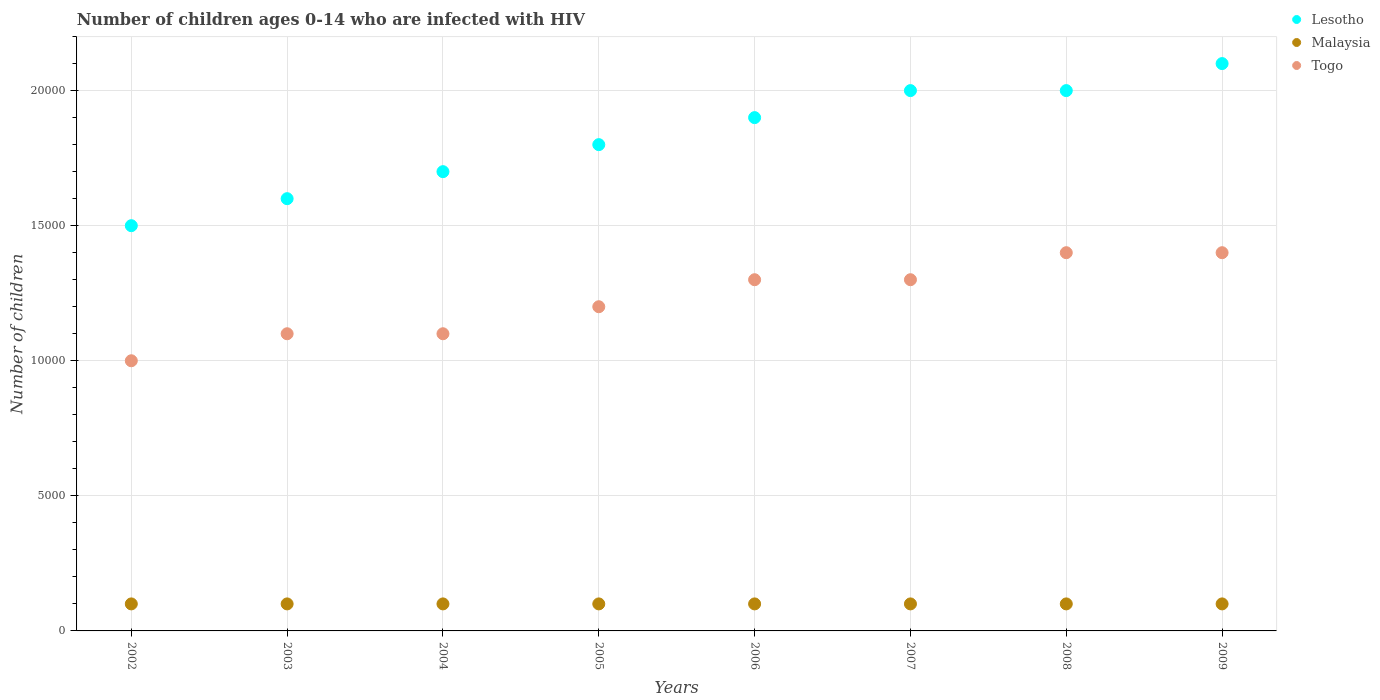Is the number of dotlines equal to the number of legend labels?
Provide a short and direct response. Yes. What is the number of HIV infected children in Lesotho in 2003?
Make the answer very short. 1.60e+04. Across all years, what is the maximum number of HIV infected children in Togo?
Your answer should be compact. 1.40e+04. Across all years, what is the minimum number of HIV infected children in Lesotho?
Your answer should be compact. 1.50e+04. In which year was the number of HIV infected children in Togo minimum?
Keep it short and to the point. 2002. What is the total number of HIV infected children in Malaysia in the graph?
Give a very brief answer. 8000. What is the difference between the number of HIV infected children in Togo in 2002 and that in 2005?
Ensure brevity in your answer.  -2000. What is the difference between the number of HIV infected children in Malaysia in 2005 and the number of HIV infected children in Togo in 2009?
Offer a very short reply. -1.30e+04. What is the average number of HIV infected children in Togo per year?
Provide a short and direct response. 1.22e+04. In the year 2004, what is the difference between the number of HIV infected children in Togo and number of HIV infected children in Lesotho?
Ensure brevity in your answer.  -6000. What is the ratio of the number of HIV infected children in Lesotho in 2006 to that in 2009?
Provide a succinct answer. 0.9. Is the number of HIV infected children in Lesotho in 2002 less than that in 2003?
Your response must be concise. Yes. What is the difference between the highest and the lowest number of HIV infected children in Lesotho?
Provide a succinct answer. 6000. In how many years, is the number of HIV infected children in Lesotho greater than the average number of HIV infected children in Lesotho taken over all years?
Keep it short and to the point. 4. Is it the case that in every year, the sum of the number of HIV infected children in Togo and number of HIV infected children in Malaysia  is greater than the number of HIV infected children in Lesotho?
Your answer should be compact. No. Is the number of HIV infected children in Togo strictly greater than the number of HIV infected children in Lesotho over the years?
Provide a succinct answer. No. How many dotlines are there?
Your answer should be compact. 3. Are the values on the major ticks of Y-axis written in scientific E-notation?
Provide a succinct answer. No. Does the graph contain grids?
Your response must be concise. Yes. How many legend labels are there?
Provide a short and direct response. 3. How are the legend labels stacked?
Keep it short and to the point. Vertical. What is the title of the graph?
Your answer should be compact. Number of children ages 0-14 who are infected with HIV. What is the label or title of the X-axis?
Offer a terse response. Years. What is the label or title of the Y-axis?
Your answer should be compact. Number of children. What is the Number of children in Lesotho in 2002?
Make the answer very short. 1.50e+04. What is the Number of children in Malaysia in 2002?
Make the answer very short. 1000. What is the Number of children of Lesotho in 2003?
Provide a short and direct response. 1.60e+04. What is the Number of children of Malaysia in 2003?
Ensure brevity in your answer.  1000. What is the Number of children of Togo in 2003?
Make the answer very short. 1.10e+04. What is the Number of children of Lesotho in 2004?
Your response must be concise. 1.70e+04. What is the Number of children in Malaysia in 2004?
Give a very brief answer. 1000. What is the Number of children of Togo in 2004?
Offer a terse response. 1.10e+04. What is the Number of children in Lesotho in 2005?
Provide a short and direct response. 1.80e+04. What is the Number of children of Malaysia in 2005?
Make the answer very short. 1000. What is the Number of children of Togo in 2005?
Your response must be concise. 1.20e+04. What is the Number of children of Lesotho in 2006?
Keep it short and to the point. 1.90e+04. What is the Number of children of Togo in 2006?
Your answer should be very brief. 1.30e+04. What is the Number of children in Lesotho in 2007?
Provide a short and direct response. 2.00e+04. What is the Number of children of Togo in 2007?
Your answer should be very brief. 1.30e+04. What is the Number of children in Lesotho in 2008?
Provide a succinct answer. 2.00e+04. What is the Number of children in Togo in 2008?
Ensure brevity in your answer.  1.40e+04. What is the Number of children of Lesotho in 2009?
Your answer should be very brief. 2.10e+04. What is the Number of children of Togo in 2009?
Keep it short and to the point. 1.40e+04. Across all years, what is the maximum Number of children of Lesotho?
Give a very brief answer. 2.10e+04. Across all years, what is the maximum Number of children of Togo?
Give a very brief answer. 1.40e+04. Across all years, what is the minimum Number of children in Lesotho?
Provide a succinct answer. 1.50e+04. Across all years, what is the minimum Number of children of Malaysia?
Ensure brevity in your answer.  1000. Across all years, what is the minimum Number of children in Togo?
Ensure brevity in your answer.  10000. What is the total Number of children of Lesotho in the graph?
Your answer should be very brief. 1.46e+05. What is the total Number of children in Malaysia in the graph?
Your answer should be compact. 8000. What is the total Number of children in Togo in the graph?
Offer a very short reply. 9.80e+04. What is the difference between the Number of children in Lesotho in 2002 and that in 2003?
Provide a short and direct response. -1000. What is the difference between the Number of children of Togo in 2002 and that in 2003?
Provide a succinct answer. -1000. What is the difference between the Number of children of Lesotho in 2002 and that in 2004?
Give a very brief answer. -2000. What is the difference between the Number of children in Togo in 2002 and that in 2004?
Give a very brief answer. -1000. What is the difference between the Number of children of Lesotho in 2002 and that in 2005?
Provide a succinct answer. -3000. What is the difference between the Number of children in Togo in 2002 and that in 2005?
Your answer should be very brief. -2000. What is the difference between the Number of children of Lesotho in 2002 and that in 2006?
Give a very brief answer. -4000. What is the difference between the Number of children in Togo in 2002 and that in 2006?
Give a very brief answer. -3000. What is the difference between the Number of children of Lesotho in 2002 and that in 2007?
Provide a short and direct response. -5000. What is the difference between the Number of children in Togo in 2002 and that in 2007?
Offer a very short reply. -3000. What is the difference between the Number of children in Lesotho in 2002 and that in 2008?
Give a very brief answer. -5000. What is the difference between the Number of children in Togo in 2002 and that in 2008?
Provide a short and direct response. -4000. What is the difference between the Number of children of Lesotho in 2002 and that in 2009?
Keep it short and to the point. -6000. What is the difference between the Number of children in Togo in 2002 and that in 2009?
Give a very brief answer. -4000. What is the difference between the Number of children of Lesotho in 2003 and that in 2004?
Provide a short and direct response. -1000. What is the difference between the Number of children in Malaysia in 2003 and that in 2004?
Your response must be concise. 0. What is the difference between the Number of children of Togo in 2003 and that in 2004?
Offer a very short reply. 0. What is the difference between the Number of children in Lesotho in 2003 and that in 2005?
Keep it short and to the point. -2000. What is the difference between the Number of children of Togo in 2003 and that in 2005?
Offer a very short reply. -1000. What is the difference between the Number of children of Lesotho in 2003 and that in 2006?
Your answer should be compact. -3000. What is the difference between the Number of children in Togo in 2003 and that in 2006?
Your answer should be very brief. -2000. What is the difference between the Number of children in Lesotho in 2003 and that in 2007?
Ensure brevity in your answer.  -4000. What is the difference between the Number of children in Malaysia in 2003 and that in 2007?
Keep it short and to the point. 0. What is the difference between the Number of children of Togo in 2003 and that in 2007?
Your response must be concise. -2000. What is the difference between the Number of children of Lesotho in 2003 and that in 2008?
Keep it short and to the point. -4000. What is the difference between the Number of children of Malaysia in 2003 and that in 2008?
Offer a terse response. 0. What is the difference between the Number of children in Togo in 2003 and that in 2008?
Provide a short and direct response. -3000. What is the difference between the Number of children in Lesotho in 2003 and that in 2009?
Offer a terse response. -5000. What is the difference between the Number of children of Malaysia in 2003 and that in 2009?
Make the answer very short. 0. What is the difference between the Number of children of Togo in 2003 and that in 2009?
Keep it short and to the point. -3000. What is the difference between the Number of children in Lesotho in 2004 and that in 2005?
Keep it short and to the point. -1000. What is the difference between the Number of children of Togo in 2004 and that in 2005?
Ensure brevity in your answer.  -1000. What is the difference between the Number of children of Lesotho in 2004 and that in 2006?
Your response must be concise. -2000. What is the difference between the Number of children in Togo in 2004 and that in 2006?
Ensure brevity in your answer.  -2000. What is the difference between the Number of children of Lesotho in 2004 and that in 2007?
Give a very brief answer. -3000. What is the difference between the Number of children of Malaysia in 2004 and that in 2007?
Provide a short and direct response. 0. What is the difference between the Number of children in Togo in 2004 and that in 2007?
Your answer should be very brief. -2000. What is the difference between the Number of children in Lesotho in 2004 and that in 2008?
Your answer should be compact. -3000. What is the difference between the Number of children of Togo in 2004 and that in 2008?
Keep it short and to the point. -3000. What is the difference between the Number of children in Lesotho in 2004 and that in 2009?
Give a very brief answer. -4000. What is the difference between the Number of children of Malaysia in 2004 and that in 2009?
Provide a short and direct response. 0. What is the difference between the Number of children in Togo in 2004 and that in 2009?
Ensure brevity in your answer.  -3000. What is the difference between the Number of children of Lesotho in 2005 and that in 2006?
Your answer should be compact. -1000. What is the difference between the Number of children of Malaysia in 2005 and that in 2006?
Your response must be concise. 0. What is the difference between the Number of children of Togo in 2005 and that in 2006?
Your answer should be compact. -1000. What is the difference between the Number of children of Lesotho in 2005 and that in 2007?
Make the answer very short. -2000. What is the difference between the Number of children of Togo in 2005 and that in 2007?
Offer a terse response. -1000. What is the difference between the Number of children in Lesotho in 2005 and that in 2008?
Make the answer very short. -2000. What is the difference between the Number of children in Malaysia in 2005 and that in 2008?
Your answer should be compact. 0. What is the difference between the Number of children in Togo in 2005 and that in 2008?
Offer a terse response. -2000. What is the difference between the Number of children in Lesotho in 2005 and that in 2009?
Provide a succinct answer. -3000. What is the difference between the Number of children in Togo in 2005 and that in 2009?
Make the answer very short. -2000. What is the difference between the Number of children in Lesotho in 2006 and that in 2007?
Your answer should be compact. -1000. What is the difference between the Number of children of Lesotho in 2006 and that in 2008?
Offer a very short reply. -1000. What is the difference between the Number of children in Togo in 2006 and that in 2008?
Offer a very short reply. -1000. What is the difference between the Number of children of Lesotho in 2006 and that in 2009?
Your answer should be compact. -2000. What is the difference between the Number of children of Togo in 2006 and that in 2009?
Your response must be concise. -1000. What is the difference between the Number of children in Togo in 2007 and that in 2008?
Your response must be concise. -1000. What is the difference between the Number of children in Lesotho in 2007 and that in 2009?
Provide a succinct answer. -1000. What is the difference between the Number of children in Malaysia in 2007 and that in 2009?
Offer a terse response. 0. What is the difference between the Number of children in Togo in 2007 and that in 2009?
Make the answer very short. -1000. What is the difference between the Number of children of Lesotho in 2008 and that in 2009?
Keep it short and to the point. -1000. What is the difference between the Number of children in Lesotho in 2002 and the Number of children in Malaysia in 2003?
Your response must be concise. 1.40e+04. What is the difference between the Number of children of Lesotho in 2002 and the Number of children of Togo in 2003?
Keep it short and to the point. 4000. What is the difference between the Number of children in Malaysia in 2002 and the Number of children in Togo in 2003?
Your response must be concise. -10000. What is the difference between the Number of children in Lesotho in 2002 and the Number of children in Malaysia in 2004?
Your answer should be very brief. 1.40e+04. What is the difference between the Number of children of Lesotho in 2002 and the Number of children of Togo in 2004?
Keep it short and to the point. 4000. What is the difference between the Number of children of Lesotho in 2002 and the Number of children of Malaysia in 2005?
Ensure brevity in your answer.  1.40e+04. What is the difference between the Number of children of Lesotho in 2002 and the Number of children of Togo in 2005?
Provide a short and direct response. 3000. What is the difference between the Number of children in Malaysia in 2002 and the Number of children in Togo in 2005?
Make the answer very short. -1.10e+04. What is the difference between the Number of children of Lesotho in 2002 and the Number of children of Malaysia in 2006?
Keep it short and to the point. 1.40e+04. What is the difference between the Number of children in Malaysia in 2002 and the Number of children in Togo in 2006?
Provide a succinct answer. -1.20e+04. What is the difference between the Number of children in Lesotho in 2002 and the Number of children in Malaysia in 2007?
Ensure brevity in your answer.  1.40e+04. What is the difference between the Number of children in Malaysia in 2002 and the Number of children in Togo in 2007?
Ensure brevity in your answer.  -1.20e+04. What is the difference between the Number of children in Lesotho in 2002 and the Number of children in Malaysia in 2008?
Make the answer very short. 1.40e+04. What is the difference between the Number of children of Malaysia in 2002 and the Number of children of Togo in 2008?
Offer a very short reply. -1.30e+04. What is the difference between the Number of children in Lesotho in 2002 and the Number of children in Malaysia in 2009?
Your response must be concise. 1.40e+04. What is the difference between the Number of children in Lesotho in 2002 and the Number of children in Togo in 2009?
Provide a short and direct response. 1000. What is the difference between the Number of children in Malaysia in 2002 and the Number of children in Togo in 2009?
Keep it short and to the point. -1.30e+04. What is the difference between the Number of children of Lesotho in 2003 and the Number of children of Malaysia in 2004?
Keep it short and to the point. 1.50e+04. What is the difference between the Number of children of Lesotho in 2003 and the Number of children of Malaysia in 2005?
Your response must be concise. 1.50e+04. What is the difference between the Number of children of Lesotho in 2003 and the Number of children of Togo in 2005?
Make the answer very short. 4000. What is the difference between the Number of children in Malaysia in 2003 and the Number of children in Togo in 2005?
Provide a short and direct response. -1.10e+04. What is the difference between the Number of children in Lesotho in 2003 and the Number of children in Malaysia in 2006?
Your response must be concise. 1.50e+04. What is the difference between the Number of children of Lesotho in 2003 and the Number of children of Togo in 2006?
Offer a very short reply. 3000. What is the difference between the Number of children in Malaysia in 2003 and the Number of children in Togo in 2006?
Your answer should be very brief. -1.20e+04. What is the difference between the Number of children in Lesotho in 2003 and the Number of children in Malaysia in 2007?
Offer a very short reply. 1.50e+04. What is the difference between the Number of children of Lesotho in 2003 and the Number of children of Togo in 2007?
Ensure brevity in your answer.  3000. What is the difference between the Number of children of Malaysia in 2003 and the Number of children of Togo in 2007?
Your response must be concise. -1.20e+04. What is the difference between the Number of children in Lesotho in 2003 and the Number of children in Malaysia in 2008?
Provide a succinct answer. 1.50e+04. What is the difference between the Number of children of Lesotho in 2003 and the Number of children of Togo in 2008?
Ensure brevity in your answer.  2000. What is the difference between the Number of children in Malaysia in 2003 and the Number of children in Togo in 2008?
Provide a succinct answer. -1.30e+04. What is the difference between the Number of children of Lesotho in 2003 and the Number of children of Malaysia in 2009?
Your answer should be compact. 1.50e+04. What is the difference between the Number of children of Malaysia in 2003 and the Number of children of Togo in 2009?
Offer a terse response. -1.30e+04. What is the difference between the Number of children of Lesotho in 2004 and the Number of children of Malaysia in 2005?
Provide a short and direct response. 1.60e+04. What is the difference between the Number of children in Lesotho in 2004 and the Number of children in Togo in 2005?
Give a very brief answer. 5000. What is the difference between the Number of children of Malaysia in 2004 and the Number of children of Togo in 2005?
Provide a succinct answer. -1.10e+04. What is the difference between the Number of children of Lesotho in 2004 and the Number of children of Malaysia in 2006?
Your answer should be very brief. 1.60e+04. What is the difference between the Number of children in Lesotho in 2004 and the Number of children in Togo in 2006?
Give a very brief answer. 4000. What is the difference between the Number of children of Malaysia in 2004 and the Number of children of Togo in 2006?
Your response must be concise. -1.20e+04. What is the difference between the Number of children of Lesotho in 2004 and the Number of children of Malaysia in 2007?
Offer a very short reply. 1.60e+04. What is the difference between the Number of children of Lesotho in 2004 and the Number of children of Togo in 2007?
Your answer should be compact. 4000. What is the difference between the Number of children of Malaysia in 2004 and the Number of children of Togo in 2007?
Your answer should be compact. -1.20e+04. What is the difference between the Number of children in Lesotho in 2004 and the Number of children in Malaysia in 2008?
Make the answer very short. 1.60e+04. What is the difference between the Number of children of Lesotho in 2004 and the Number of children of Togo in 2008?
Offer a terse response. 3000. What is the difference between the Number of children of Malaysia in 2004 and the Number of children of Togo in 2008?
Keep it short and to the point. -1.30e+04. What is the difference between the Number of children in Lesotho in 2004 and the Number of children in Malaysia in 2009?
Your response must be concise. 1.60e+04. What is the difference between the Number of children in Lesotho in 2004 and the Number of children in Togo in 2009?
Give a very brief answer. 3000. What is the difference between the Number of children of Malaysia in 2004 and the Number of children of Togo in 2009?
Provide a succinct answer. -1.30e+04. What is the difference between the Number of children in Lesotho in 2005 and the Number of children in Malaysia in 2006?
Offer a very short reply. 1.70e+04. What is the difference between the Number of children in Lesotho in 2005 and the Number of children in Togo in 2006?
Your answer should be compact. 5000. What is the difference between the Number of children of Malaysia in 2005 and the Number of children of Togo in 2006?
Your response must be concise. -1.20e+04. What is the difference between the Number of children in Lesotho in 2005 and the Number of children in Malaysia in 2007?
Keep it short and to the point. 1.70e+04. What is the difference between the Number of children in Lesotho in 2005 and the Number of children in Togo in 2007?
Give a very brief answer. 5000. What is the difference between the Number of children in Malaysia in 2005 and the Number of children in Togo in 2007?
Provide a succinct answer. -1.20e+04. What is the difference between the Number of children of Lesotho in 2005 and the Number of children of Malaysia in 2008?
Your response must be concise. 1.70e+04. What is the difference between the Number of children in Lesotho in 2005 and the Number of children in Togo in 2008?
Provide a succinct answer. 4000. What is the difference between the Number of children of Malaysia in 2005 and the Number of children of Togo in 2008?
Provide a short and direct response. -1.30e+04. What is the difference between the Number of children in Lesotho in 2005 and the Number of children in Malaysia in 2009?
Your answer should be compact. 1.70e+04. What is the difference between the Number of children in Lesotho in 2005 and the Number of children in Togo in 2009?
Keep it short and to the point. 4000. What is the difference between the Number of children of Malaysia in 2005 and the Number of children of Togo in 2009?
Give a very brief answer. -1.30e+04. What is the difference between the Number of children in Lesotho in 2006 and the Number of children in Malaysia in 2007?
Offer a terse response. 1.80e+04. What is the difference between the Number of children of Lesotho in 2006 and the Number of children of Togo in 2007?
Provide a short and direct response. 6000. What is the difference between the Number of children in Malaysia in 2006 and the Number of children in Togo in 2007?
Your answer should be very brief. -1.20e+04. What is the difference between the Number of children in Lesotho in 2006 and the Number of children in Malaysia in 2008?
Your answer should be very brief. 1.80e+04. What is the difference between the Number of children in Lesotho in 2006 and the Number of children in Togo in 2008?
Provide a succinct answer. 5000. What is the difference between the Number of children in Malaysia in 2006 and the Number of children in Togo in 2008?
Offer a terse response. -1.30e+04. What is the difference between the Number of children in Lesotho in 2006 and the Number of children in Malaysia in 2009?
Your response must be concise. 1.80e+04. What is the difference between the Number of children in Malaysia in 2006 and the Number of children in Togo in 2009?
Your answer should be very brief. -1.30e+04. What is the difference between the Number of children of Lesotho in 2007 and the Number of children of Malaysia in 2008?
Your answer should be very brief. 1.90e+04. What is the difference between the Number of children of Lesotho in 2007 and the Number of children of Togo in 2008?
Offer a very short reply. 6000. What is the difference between the Number of children of Malaysia in 2007 and the Number of children of Togo in 2008?
Offer a terse response. -1.30e+04. What is the difference between the Number of children in Lesotho in 2007 and the Number of children in Malaysia in 2009?
Offer a very short reply. 1.90e+04. What is the difference between the Number of children of Lesotho in 2007 and the Number of children of Togo in 2009?
Offer a very short reply. 6000. What is the difference between the Number of children of Malaysia in 2007 and the Number of children of Togo in 2009?
Offer a terse response. -1.30e+04. What is the difference between the Number of children of Lesotho in 2008 and the Number of children of Malaysia in 2009?
Make the answer very short. 1.90e+04. What is the difference between the Number of children in Lesotho in 2008 and the Number of children in Togo in 2009?
Provide a succinct answer. 6000. What is the difference between the Number of children in Malaysia in 2008 and the Number of children in Togo in 2009?
Provide a short and direct response. -1.30e+04. What is the average Number of children of Lesotho per year?
Give a very brief answer. 1.82e+04. What is the average Number of children in Togo per year?
Make the answer very short. 1.22e+04. In the year 2002, what is the difference between the Number of children in Lesotho and Number of children in Malaysia?
Your answer should be very brief. 1.40e+04. In the year 2002, what is the difference between the Number of children in Malaysia and Number of children in Togo?
Your answer should be compact. -9000. In the year 2003, what is the difference between the Number of children in Lesotho and Number of children in Malaysia?
Your response must be concise. 1.50e+04. In the year 2003, what is the difference between the Number of children in Malaysia and Number of children in Togo?
Provide a succinct answer. -10000. In the year 2004, what is the difference between the Number of children in Lesotho and Number of children in Malaysia?
Provide a succinct answer. 1.60e+04. In the year 2004, what is the difference between the Number of children of Lesotho and Number of children of Togo?
Your response must be concise. 6000. In the year 2004, what is the difference between the Number of children in Malaysia and Number of children in Togo?
Offer a terse response. -10000. In the year 2005, what is the difference between the Number of children in Lesotho and Number of children in Malaysia?
Your answer should be compact. 1.70e+04. In the year 2005, what is the difference between the Number of children in Lesotho and Number of children in Togo?
Your answer should be very brief. 6000. In the year 2005, what is the difference between the Number of children in Malaysia and Number of children in Togo?
Your answer should be very brief. -1.10e+04. In the year 2006, what is the difference between the Number of children in Lesotho and Number of children in Malaysia?
Your response must be concise. 1.80e+04. In the year 2006, what is the difference between the Number of children of Lesotho and Number of children of Togo?
Your answer should be very brief. 6000. In the year 2006, what is the difference between the Number of children in Malaysia and Number of children in Togo?
Your response must be concise. -1.20e+04. In the year 2007, what is the difference between the Number of children in Lesotho and Number of children in Malaysia?
Keep it short and to the point. 1.90e+04. In the year 2007, what is the difference between the Number of children in Lesotho and Number of children in Togo?
Make the answer very short. 7000. In the year 2007, what is the difference between the Number of children of Malaysia and Number of children of Togo?
Provide a succinct answer. -1.20e+04. In the year 2008, what is the difference between the Number of children in Lesotho and Number of children in Malaysia?
Keep it short and to the point. 1.90e+04. In the year 2008, what is the difference between the Number of children of Lesotho and Number of children of Togo?
Your answer should be very brief. 6000. In the year 2008, what is the difference between the Number of children in Malaysia and Number of children in Togo?
Give a very brief answer. -1.30e+04. In the year 2009, what is the difference between the Number of children of Lesotho and Number of children of Togo?
Offer a very short reply. 7000. In the year 2009, what is the difference between the Number of children of Malaysia and Number of children of Togo?
Your answer should be compact. -1.30e+04. What is the ratio of the Number of children of Lesotho in 2002 to that in 2004?
Your answer should be compact. 0.88. What is the ratio of the Number of children in Malaysia in 2002 to that in 2004?
Ensure brevity in your answer.  1. What is the ratio of the Number of children of Lesotho in 2002 to that in 2005?
Make the answer very short. 0.83. What is the ratio of the Number of children of Malaysia in 2002 to that in 2005?
Keep it short and to the point. 1. What is the ratio of the Number of children in Togo in 2002 to that in 2005?
Provide a succinct answer. 0.83. What is the ratio of the Number of children in Lesotho in 2002 to that in 2006?
Make the answer very short. 0.79. What is the ratio of the Number of children of Togo in 2002 to that in 2006?
Provide a succinct answer. 0.77. What is the ratio of the Number of children of Lesotho in 2002 to that in 2007?
Provide a succinct answer. 0.75. What is the ratio of the Number of children in Togo in 2002 to that in 2007?
Your answer should be very brief. 0.77. What is the ratio of the Number of children in Malaysia in 2002 to that in 2008?
Provide a short and direct response. 1. What is the ratio of the Number of children in Lesotho in 2002 to that in 2009?
Offer a terse response. 0.71. What is the ratio of the Number of children of Malaysia in 2002 to that in 2009?
Your answer should be very brief. 1. What is the ratio of the Number of children of Togo in 2002 to that in 2009?
Give a very brief answer. 0.71. What is the ratio of the Number of children in Lesotho in 2003 to that in 2004?
Your response must be concise. 0.94. What is the ratio of the Number of children in Malaysia in 2003 to that in 2004?
Keep it short and to the point. 1. What is the ratio of the Number of children in Togo in 2003 to that in 2004?
Provide a succinct answer. 1. What is the ratio of the Number of children of Lesotho in 2003 to that in 2006?
Ensure brevity in your answer.  0.84. What is the ratio of the Number of children in Togo in 2003 to that in 2006?
Your response must be concise. 0.85. What is the ratio of the Number of children of Lesotho in 2003 to that in 2007?
Make the answer very short. 0.8. What is the ratio of the Number of children in Malaysia in 2003 to that in 2007?
Make the answer very short. 1. What is the ratio of the Number of children of Togo in 2003 to that in 2007?
Give a very brief answer. 0.85. What is the ratio of the Number of children of Togo in 2003 to that in 2008?
Provide a short and direct response. 0.79. What is the ratio of the Number of children in Lesotho in 2003 to that in 2009?
Your answer should be very brief. 0.76. What is the ratio of the Number of children of Malaysia in 2003 to that in 2009?
Ensure brevity in your answer.  1. What is the ratio of the Number of children of Togo in 2003 to that in 2009?
Ensure brevity in your answer.  0.79. What is the ratio of the Number of children of Lesotho in 2004 to that in 2005?
Provide a succinct answer. 0.94. What is the ratio of the Number of children in Lesotho in 2004 to that in 2006?
Your response must be concise. 0.89. What is the ratio of the Number of children in Malaysia in 2004 to that in 2006?
Provide a succinct answer. 1. What is the ratio of the Number of children in Togo in 2004 to that in 2006?
Provide a short and direct response. 0.85. What is the ratio of the Number of children in Lesotho in 2004 to that in 2007?
Your answer should be very brief. 0.85. What is the ratio of the Number of children of Togo in 2004 to that in 2007?
Your response must be concise. 0.85. What is the ratio of the Number of children in Lesotho in 2004 to that in 2008?
Your answer should be compact. 0.85. What is the ratio of the Number of children of Togo in 2004 to that in 2008?
Your answer should be very brief. 0.79. What is the ratio of the Number of children of Lesotho in 2004 to that in 2009?
Your answer should be very brief. 0.81. What is the ratio of the Number of children of Malaysia in 2004 to that in 2009?
Offer a terse response. 1. What is the ratio of the Number of children of Togo in 2004 to that in 2009?
Provide a succinct answer. 0.79. What is the ratio of the Number of children in Malaysia in 2005 to that in 2006?
Offer a very short reply. 1. What is the ratio of the Number of children in Togo in 2005 to that in 2006?
Your response must be concise. 0.92. What is the ratio of the Number of children in Lesotho in 2005 to that in 2007?
Your answer should be very brief. 0.9. What is the ratio of the Number of children in Lesotho in 2005 to that in 2008?
Give a very brief answer. 0.9. What is the ratio of the Number of children in Togo in 2005 to that in 2008?
Provide a short and direct response. 0.86. What is the ratio of the Number of children in Malaysia in 2005 to that in 2009?
Keep it short and to the point. 1. What is the ratio of the Number of children in Malaysia in 2006 to that in 2007?
Offer a very short reply. 1. What is the ratio of the Number of children in Togo in 2006 to that in 2007?
Provide a succinct answer. 1. What is the ratio of the Number of children in Togo in 2006 to that in 2008?
Offer a very short reply. 0.93. What is the ratio of the Number of children of Lesotho in 2006 to that in 2009?
Keep it short and to the point. 0.9. What is the ratio of the Number of children in Togo in 2006 to that in 2009?
Offer a terse response. 0.93. What is the ratio of the Number of children of Malaysia in 2007 to that in 2008?
Your response must be concise. 1. What is the ratio of the Number of children of Togo in 2007 to that in 2008?
Keep it short and to the point. 0.93. What is the ratio of the Number of children in Lesotho in 2007 to that in 2009?
Your response must be concise. 0.95. What is the ratio of the Number of children of Togo in 2007 to that in 2009?
Provide a succinct answer. 0.93. What is the ratio of the Number of children in Lesotho in 2008 to that in 2009?
Offer a terse response. 0.95. What is the difference between the highest and the second highest Number of children in Togo?
Your answer should be compact. 0. What is the difference between the highest and the lowest Number of children in Lesotho?
Your response must be concise. 6000. What is the difference between the highest and the lowest Number of children in Malaysia?
Your answer should be compact. 0. What is the difference between the highest and the lowest Number of children in Togo?
Offer a very short reply. 4000. 